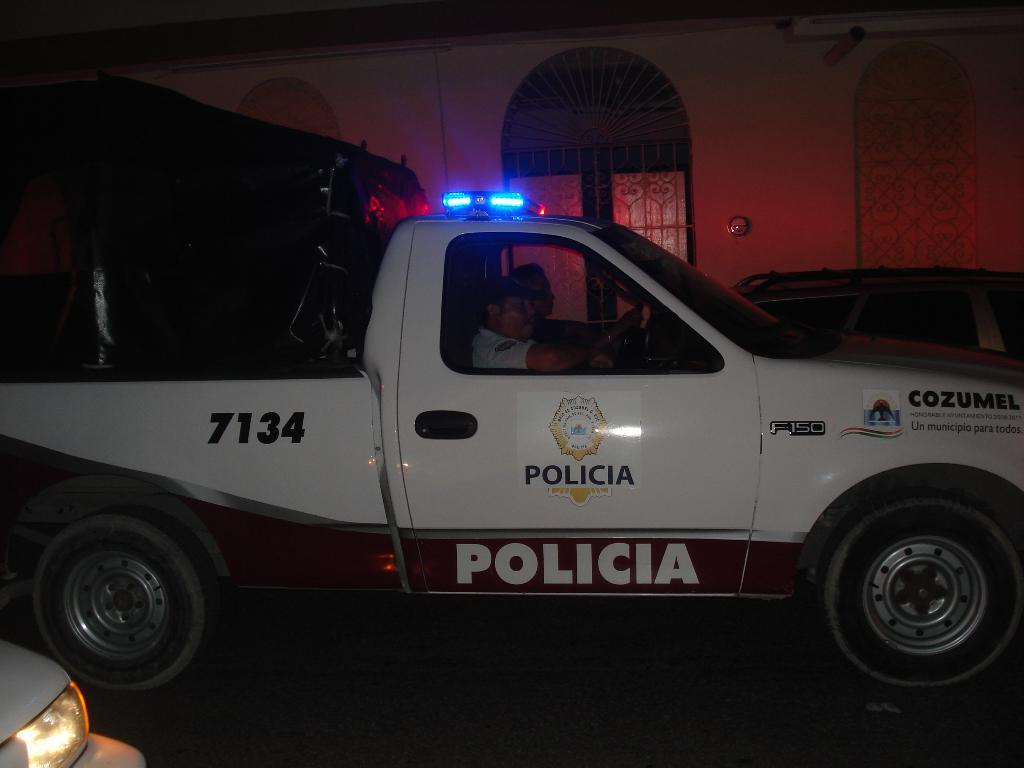What is the main subject in the foreground of the image? There is a car on the road in the foreground of the image. Who is inside the car? Two persons are sitting in the car. What can be seen in the background of the image? There is a building wall and a door in the background of the image. What time of day was the image taken? The image was taken during nighttime. What type of plant is the queen holding in the image? There is no queen or plant present in the image; it features a car on the road with two persons inside. Is the sweater visible in the image? There is no sweater present in the image. 